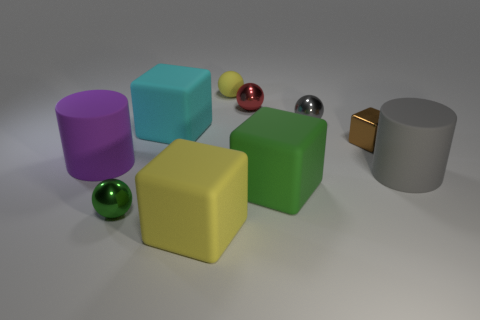Subtract 1 balls. How many balls are left? 3 Subtract all balls. How many objects are left? 6 Add 6 big cyan matte objects. How many big cyan matte objects exist? 7 Subtract 0 brown cylinders. How many objects are left? 10 Subtract all small shiny things. Subtract all big gray objects. How many objects are left? 5 Add 2 large gray rubber things. How many large gray rubber things are left? 3 